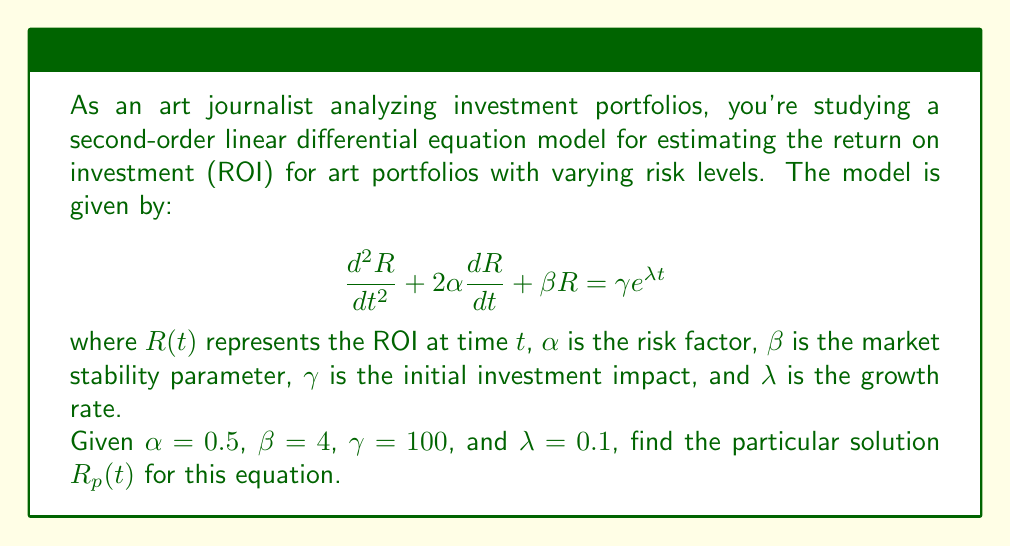Give your solution to this math problem. To find the particular solution, we'll use the method of undetermined coefficients:

1) The right-hand side of the equation has the form $\gamma e^{\lambda t}$, so we assume a particular solution of the form:

   $R_p(t) = A e^{\lambda t}$

2) We need to find $\frac{dR_p}{dt}$ and $\frac{d^2R_p}{dt^2}$:

   $\frac{dR_p}{dt} = A\lambda e^{\lambda t}$
   $\frac{d^2R_p}{dt^2} = A\lambda^2 e^{\lambda t}$

3) Substitute these into the original equation:

   $A\lambda^2 e^{\lambda t} + 2\alpha A\lambda e^{\lambda t} + \beta A e^{\lambda t} = \gamma e^{\lambda t}$

4) Simplify:

   $A(\lambda^2 + 2\alpha\lambda + \beta) e^{\lambda t} = \gamma e^{\lambda t}$

5) Equate coefficients:

   $A(\lambda^2 + 2\alpha\lambda + \beta) = \gamma$

6) Solve for $A$:

   $A = \frac{\gamma}{\lambda^2 + 2\alpha\lambda + \beta}$

7) Substitute the given values:

   $A = \frac{100}{0.1^2 + 2(0.5)(0.1) + 4} = \frac{100}{4.11} \approx 24.33$

8) Therefore, the particular solution is:

   $R_p(t) = 24.33 e^{0.1t}$
Answer: $R_p(t) = 24.33 e^{0.1t}$ 